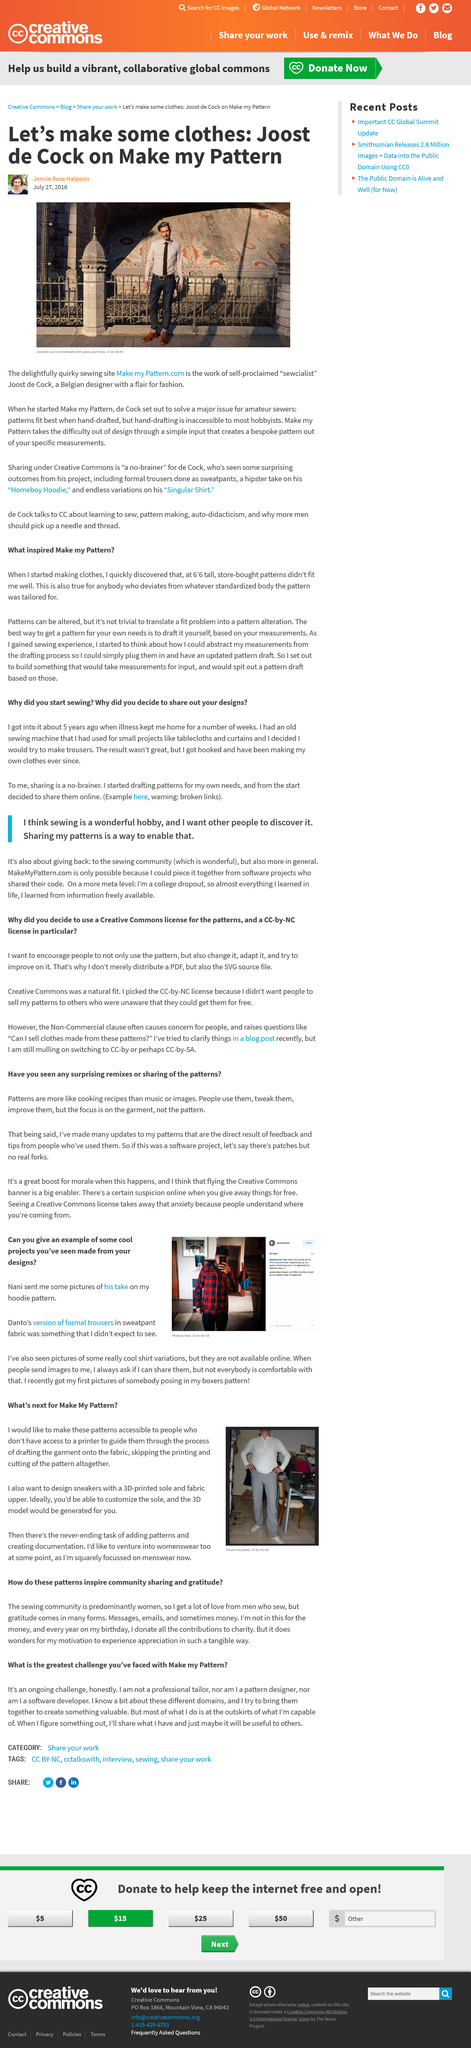List a handful of essential elements in this visual. The authors plan to create the next garment they will make using 3D technology, and the type of garment is shoes. The author intends to expand beyond men's wear and venture into womenswear. The picture on Instagram has 42 likes. Nani has submitted pictures of his personal interpretations of the hoodie pattern, and these projects are considered to be particularly impressive and innovative. The author did not graduate from college. 